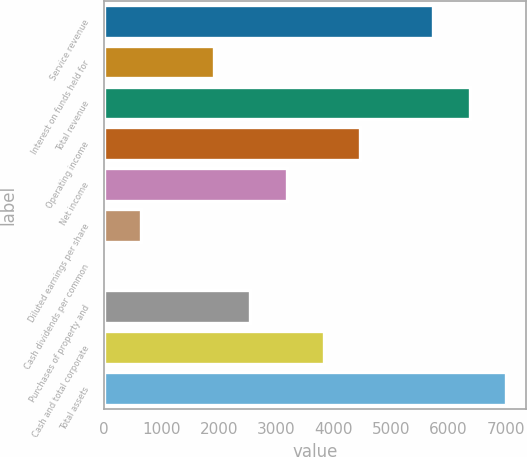Convert chart. <chart><loc_0><loc_0><loc_500><loc_500><bar_chart><fcel>Service revenue<fcel>Interest on funds held for<fcel>Total revenue<fcel>Operating income<fcel>Net income<fcel>Diluted earnings per share<fcel>Cash dividends per common<fcel>Purchases of property and<fcel>Cash and total corporate<fcel>Total assets<nl><fcel>5733.23<fcel>1912.01<fcel>6370.1<fcel>4459.49<fcel>3185.75<fcel>638.27<fcel>1.4<fcel>2548.88<fcel>3822.62<fcel>7006.97<nl></chart> 